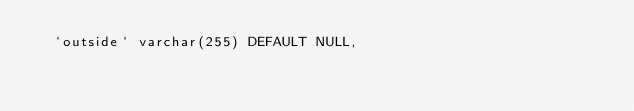<code> <loc_0><loc_0><loc_500><loc_500><_SQL_>  `outside` varchar(255) DEFAULT NULL,</code> 